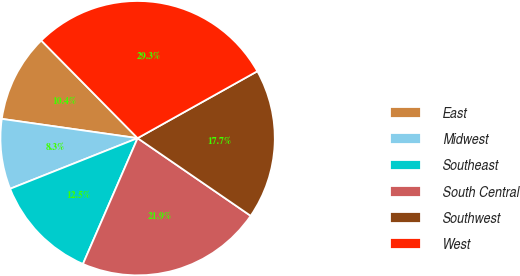<chart> <loc_0><loc_0><loc_500><loc_500><pie_chart><fcel>East<fcel>Midwest<fcel>Southeast<fcel>South Central<fcel>Southwest<fcel>West<nl><fcel>10.36%<fcel>8.26%<fcel>12.46%<fcel>21.94%<fcel>17.69%<fcel>29.28%<nl></chart> 